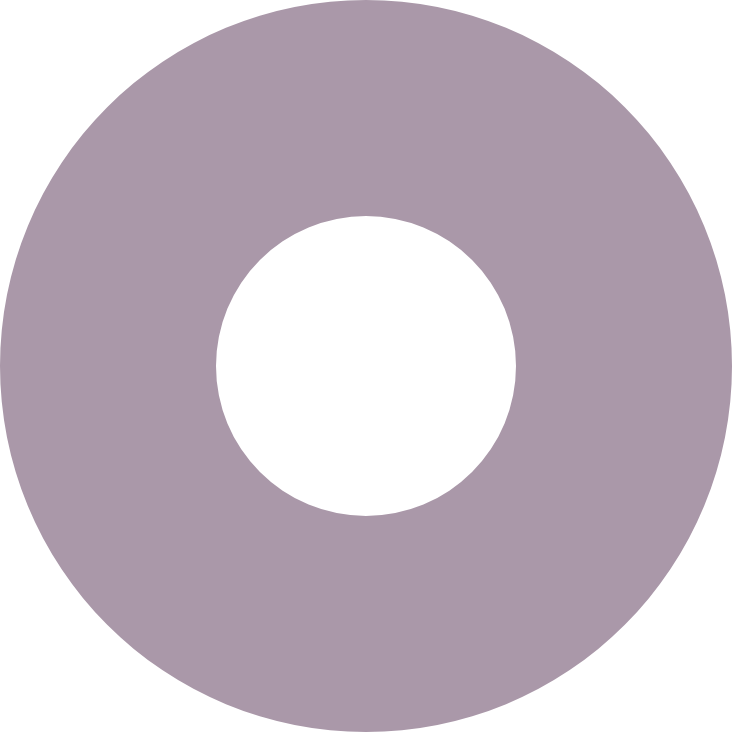<chart> <loc_0><loc_0><loc_500><loc_500><pie_chart><ecel><nl><fcel>100.0%<nl></chart> 